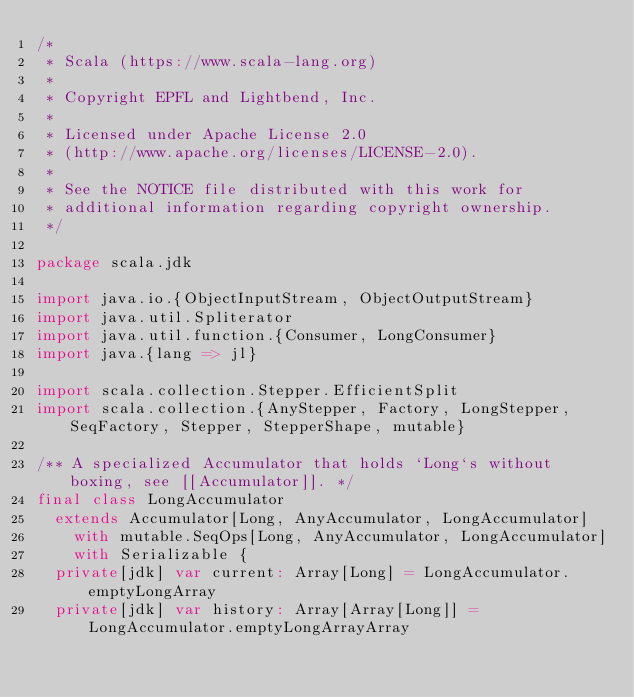<code> <loc_0><loc_0><loc_500><loc_500><_Scala_>/*
 * Scala (https://www.scala-lang.org)
 *
 * Copyright EPFL and Lightbend, Inc.
 *
 * Licensed under Apache License 2.0
 * (http://www.apache.org/licenses/LICENSE-2.0).
 *
 * See the NOTICE file distributed with this work for
 * additional information regarding copyright ownership.
 */

package scala.jdk

import java.io.{ObjectInputStream, ObjectOutputStream}
import java.util.Spliterator
import java.util.function.{Consumer, LongConsumer}
import java.{lang => jl}

import scala.collection.Stepper.EfficientSplit
import scala.collection.{AnyStepper, Factory, LongStepper, SeqFactory, Stepper, StepperShape, mutable}

/** A specialized Accumulator that holds `Long`s without boxing, see [[Accumulator]]. */
final class LongAccumulator
  extends Accumulator[Long, AnyAccumulator, LongAccumulator]
    with mutable.SeqOps[Long, AnyAccumulator, LongAccumulator]
    with Serializable {
  private[jdk] var current: Array[Long] = LongAccumulator.emptyLongArray
  private[jdk] var history: Array[Array[Long]] = LongAccumulator.emptyLongArrayArray
</code> 